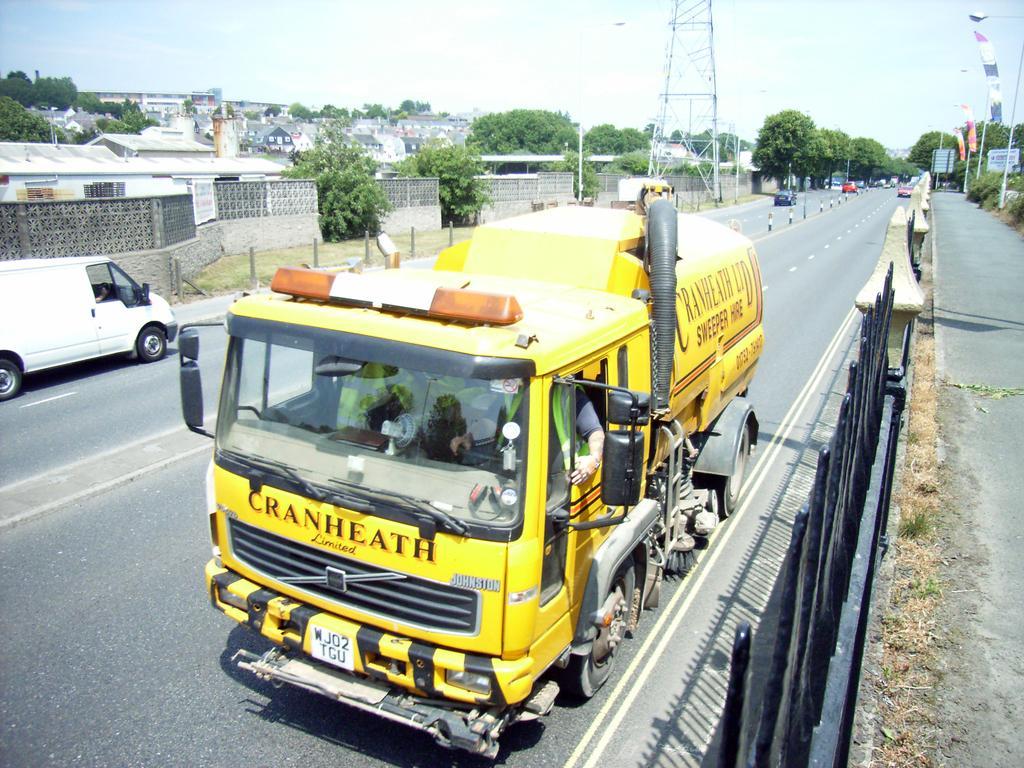Can you describe this image briefly? In this image at the center there are vehicles on the road. At the left side of the image there are buildings, trees, tower, street lights. 